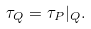<formula> <loc_0><loc_0><loc_500><loc_500>\tau _ { Q } = \tau _ { P } | _ { Q } .</formula> 